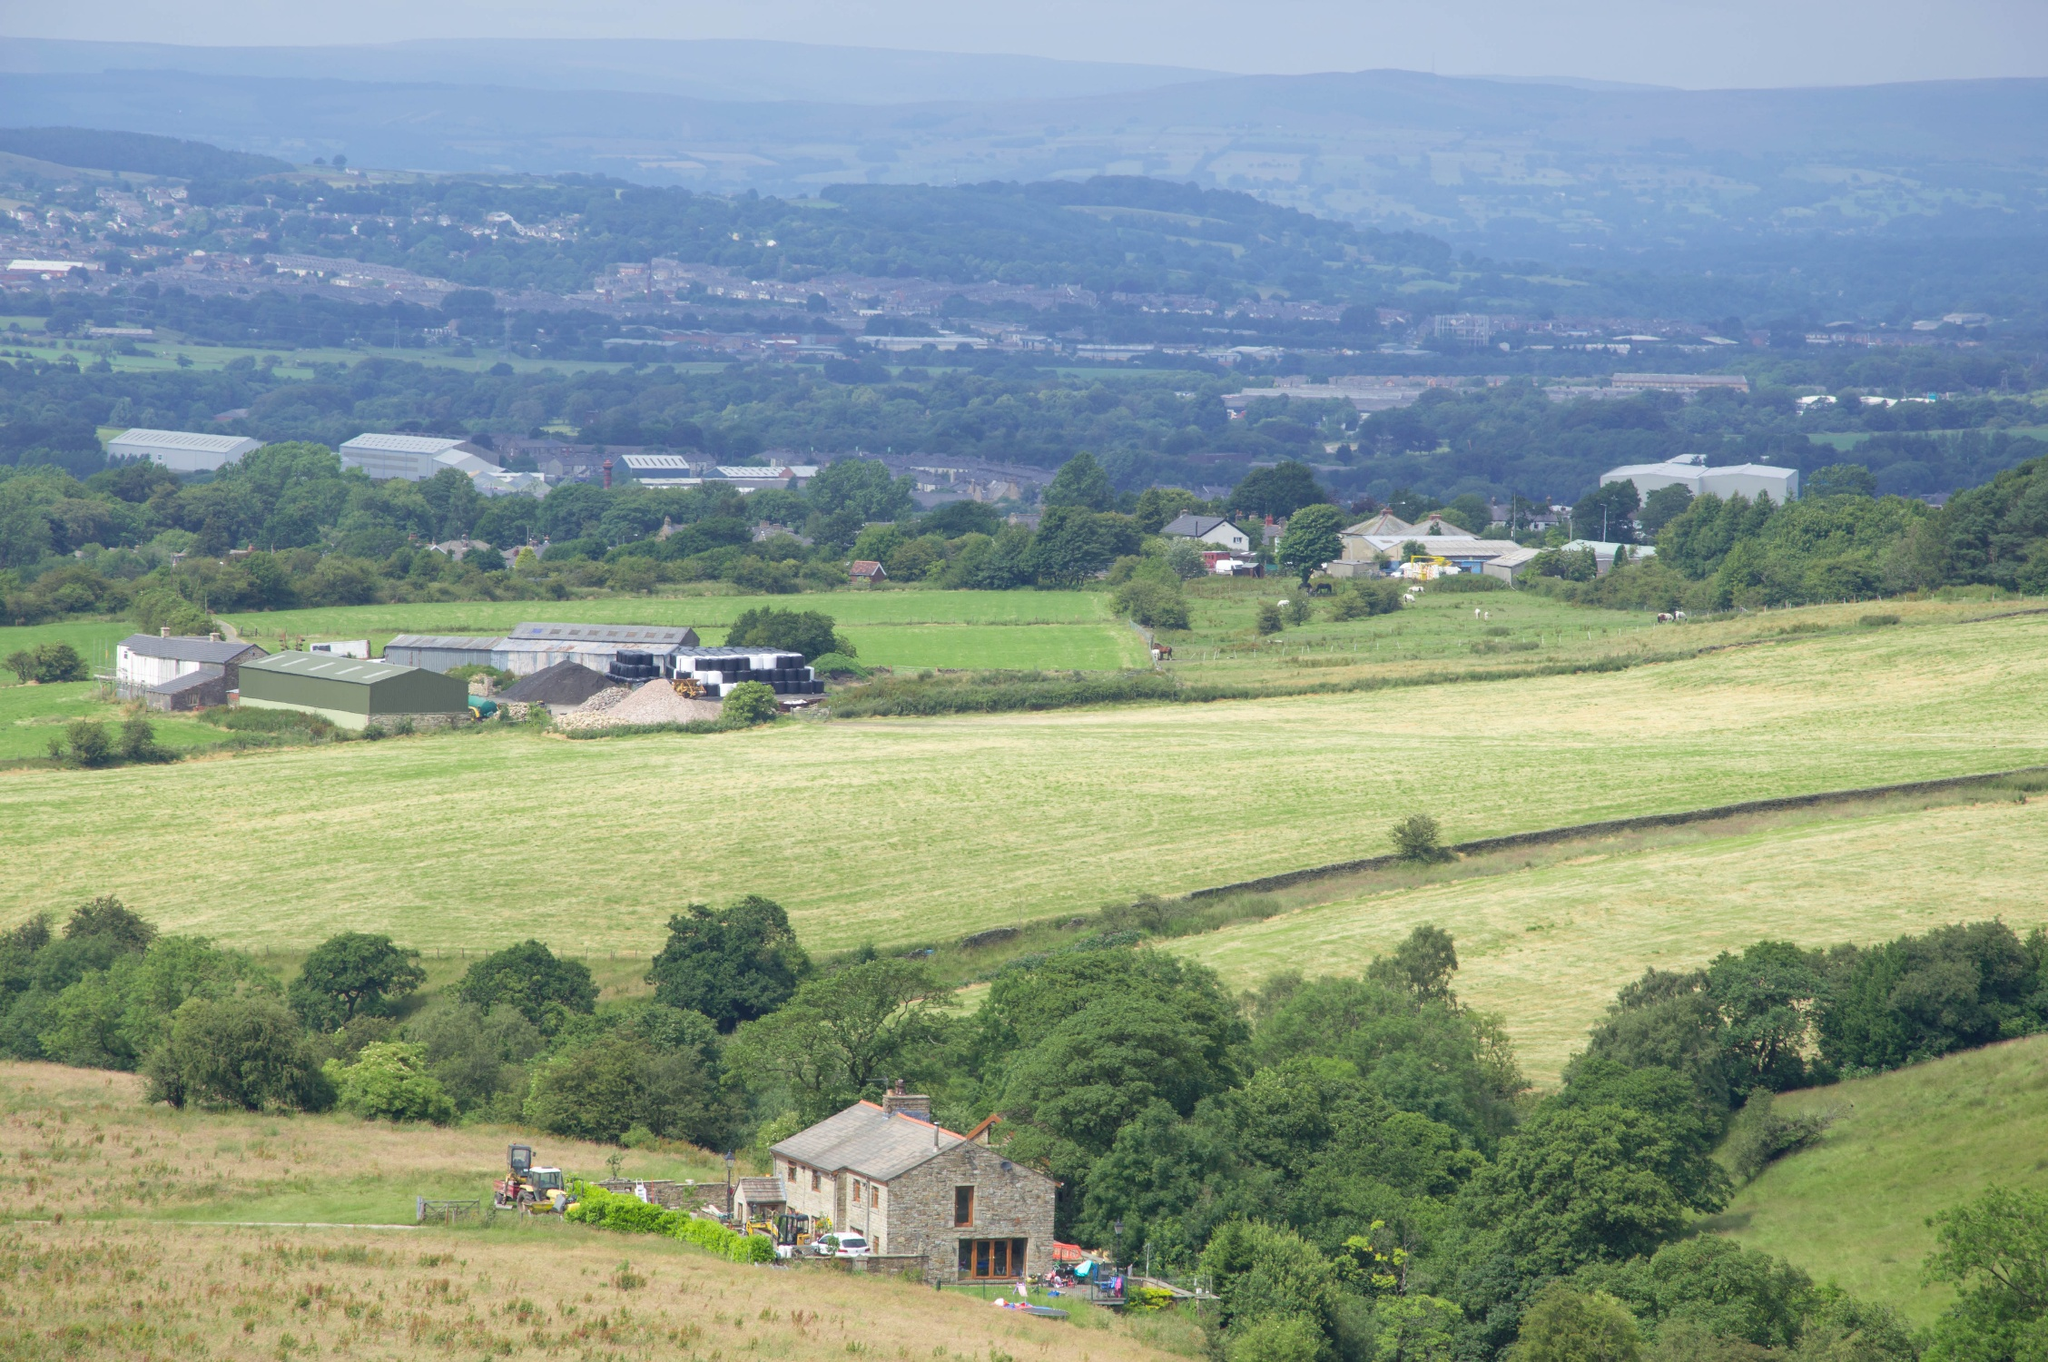Can you tell me more about the type of agriculture visible in this countryside scene? This image prominently features fields that are likely involved in mixed farming. The green areas suggest the presence of cereal crops or perhaps pasture for grazing animals, while the yellow patches might be fields that have been recently harvested or are possibly used for growing crops like wheat or barley. The landscape's structured patchwork hints at a well-planned agricultural practice possibly supported by crop rotation to maintain soil fertility and control pests and diseases. 